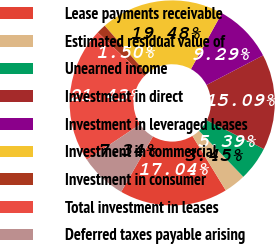<chart> <loc_0><loc_0><loc_500><loc_500><pie_chart><fcel>Lease payments receivable<fcel>Estimated residual value of<fcel>Unearned income<fcel>Investment in direct<fcel>Investment in leveraged leases<fcel>Investment in commercial<fcel>Investment in consumer<fcel>Total investment in leases<fcel>Deferred taxes payable arising<nl><fcel>17.04%<fcel>3.45%<fcel>5.39%<fcel>15.09%<fcel>9.29%<fcel>19.48%<fcel>1.5%<fcel>21.43%<fcel>7.34%<nl></chart> 